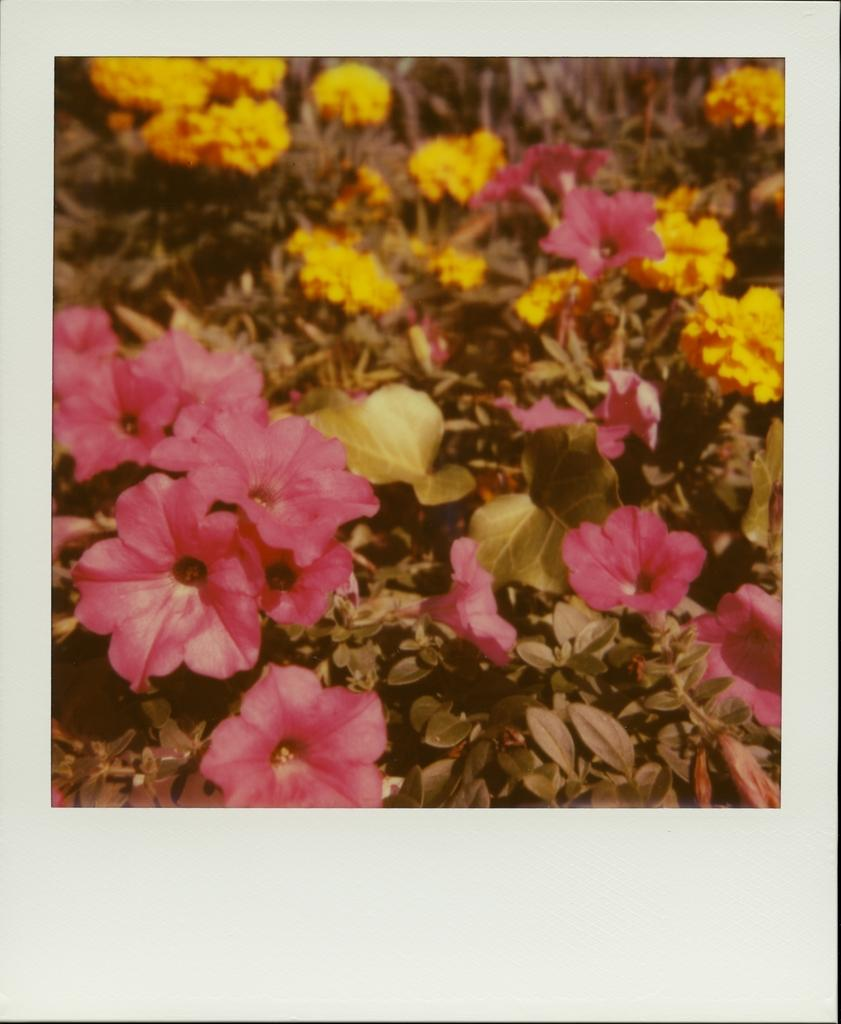What is the main subject of the image? There is a photograph in the image. What types of flowers are present in the photograph? The photograph contains pink flower plants and yellow flower plants. How does the taste of the flowers in the photograph compare to that of men? The image does not provide any information about the taste of the flowers or men, as it only shows a photograph of the flowers. 